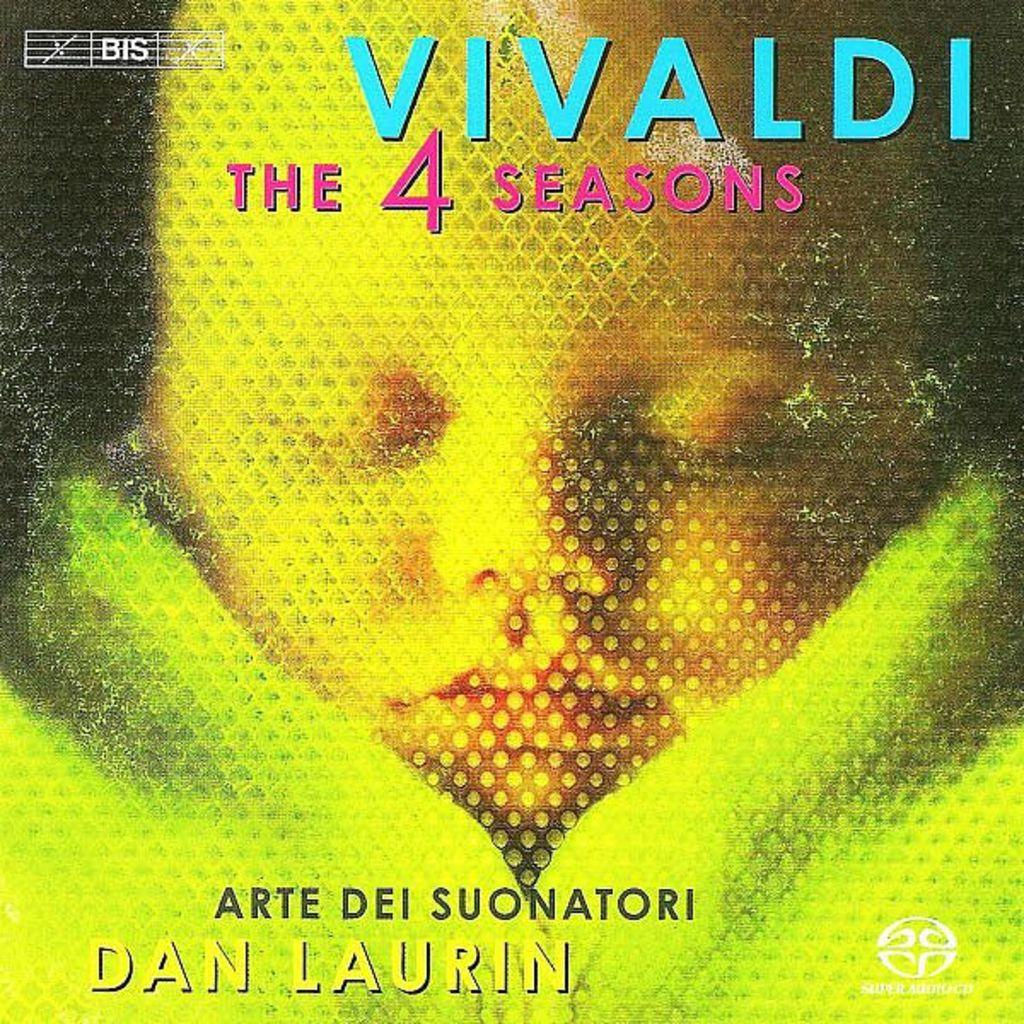Provide a one-sentence caption for the provided image. magazine cover from vivaldi seasons 4 by dan laurin. 